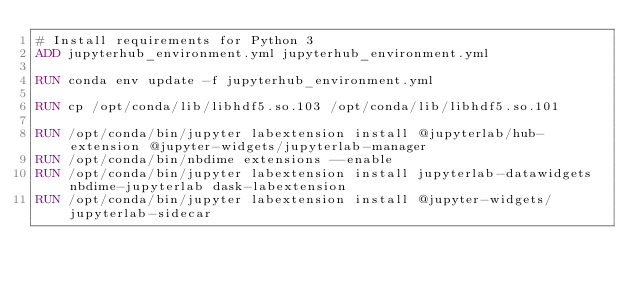<code> <loc_0><loc_0><loc_500><loc_500><_Dockerfile_># Install requirements for Python 3
ADD jupyterhub_environment.yml jupyterhub_environment.yml

RUN conda env update -f jupyterhub_environment.yml

RUN cp /opt/conda/lib/libhdf5.so.103 /opt/conda/lib/libhdf5.so.101

RUN /opt/conda/bin/jupyter labextension install @jupyterlab/hub-extension @jupyter-widgets/jupyterlab-manager
RUN /opt/conda/bin/nbdime extensions --enable
RUN /opt/conda/bin/jupyter labextension install jupyterlab-datawidgets nbdime-jupyterlab dask-labextension
RUN /opt/conda/bin/jupyter labextension install @jupyter-widgets/jupyterlab-sidecar
</code> 